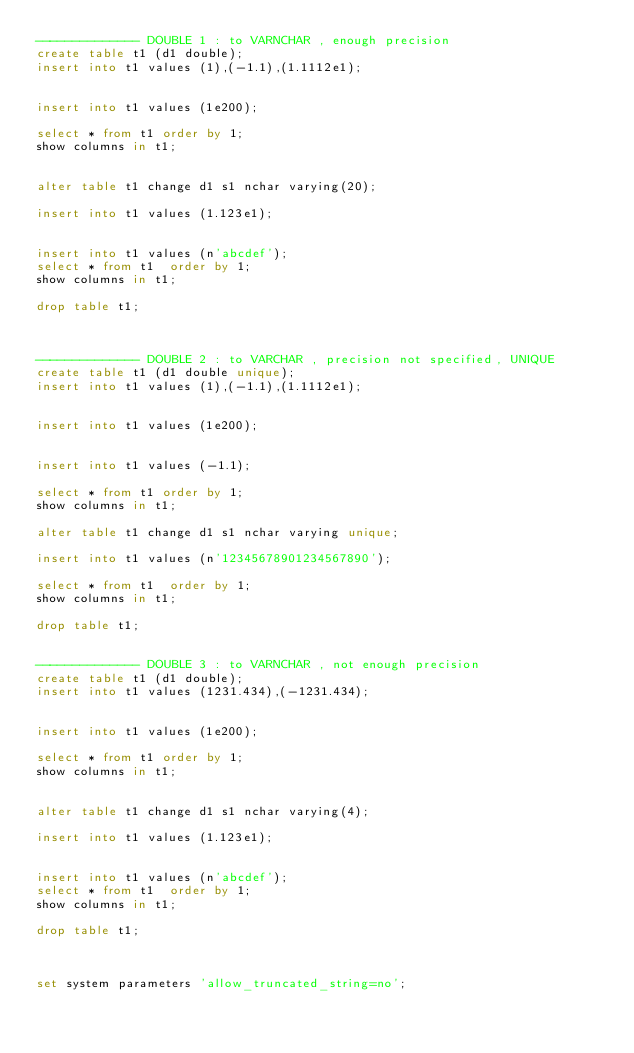Convert code to text. <code><loc_0><loc_0><loc_500><loc_500><_SQL_>-------------- DOUBLE 1 : to VARNCHAR , enough precision
create table t1 (d1 double);
insert into t1 values (1),(-1.1),(1.1112e1);


insert into t1 values (1e200);

select * from t1 order by 1;
show columns in t1;

 
alter table t1 change d1 s1 nchar varying(20);
 
insert into t1 values (1.123e1);

 
insert into t1 values (n'abcdef');
select * from t1  order by 1;
show columns in t1;

drop table t1;



-------------- DOUBLE 2 : to VARCHAR , precision not specified, UNIQUE
create table t1 (d1 double unique);
insert into t1 values (1),(-1.1),(1.1112e1);


insert into t1 values (1e200);


insert into t1 values (-1.1);

select * from t1 order by 1;
show columns in t1;

alter table t1 change d1 s1 nchar varying unique;
 
insert into t1 values (n'12345678901234567890');

select * from t1  order by 1;
show columns in t1;

drop table t1;


-------------- DOUBLE 3 : to VARNCHAR , not enough precision
create table t1 (d1 double);
insert into t1 values (1231.434),(-1231.434);


insert into t1 values (1e200);

select * from t1 order by 1;
show columns in t1;

 
alter table t1 change d1 s1 nchar varying(4);
 
insert into t1 values (1.123e1);

 
insert into t1 values (n'abcdef');
select * from t1  order by 1;
show columns in t1;

drop table t1;



set system parameters 'allow_truncated_string=no';</code> 